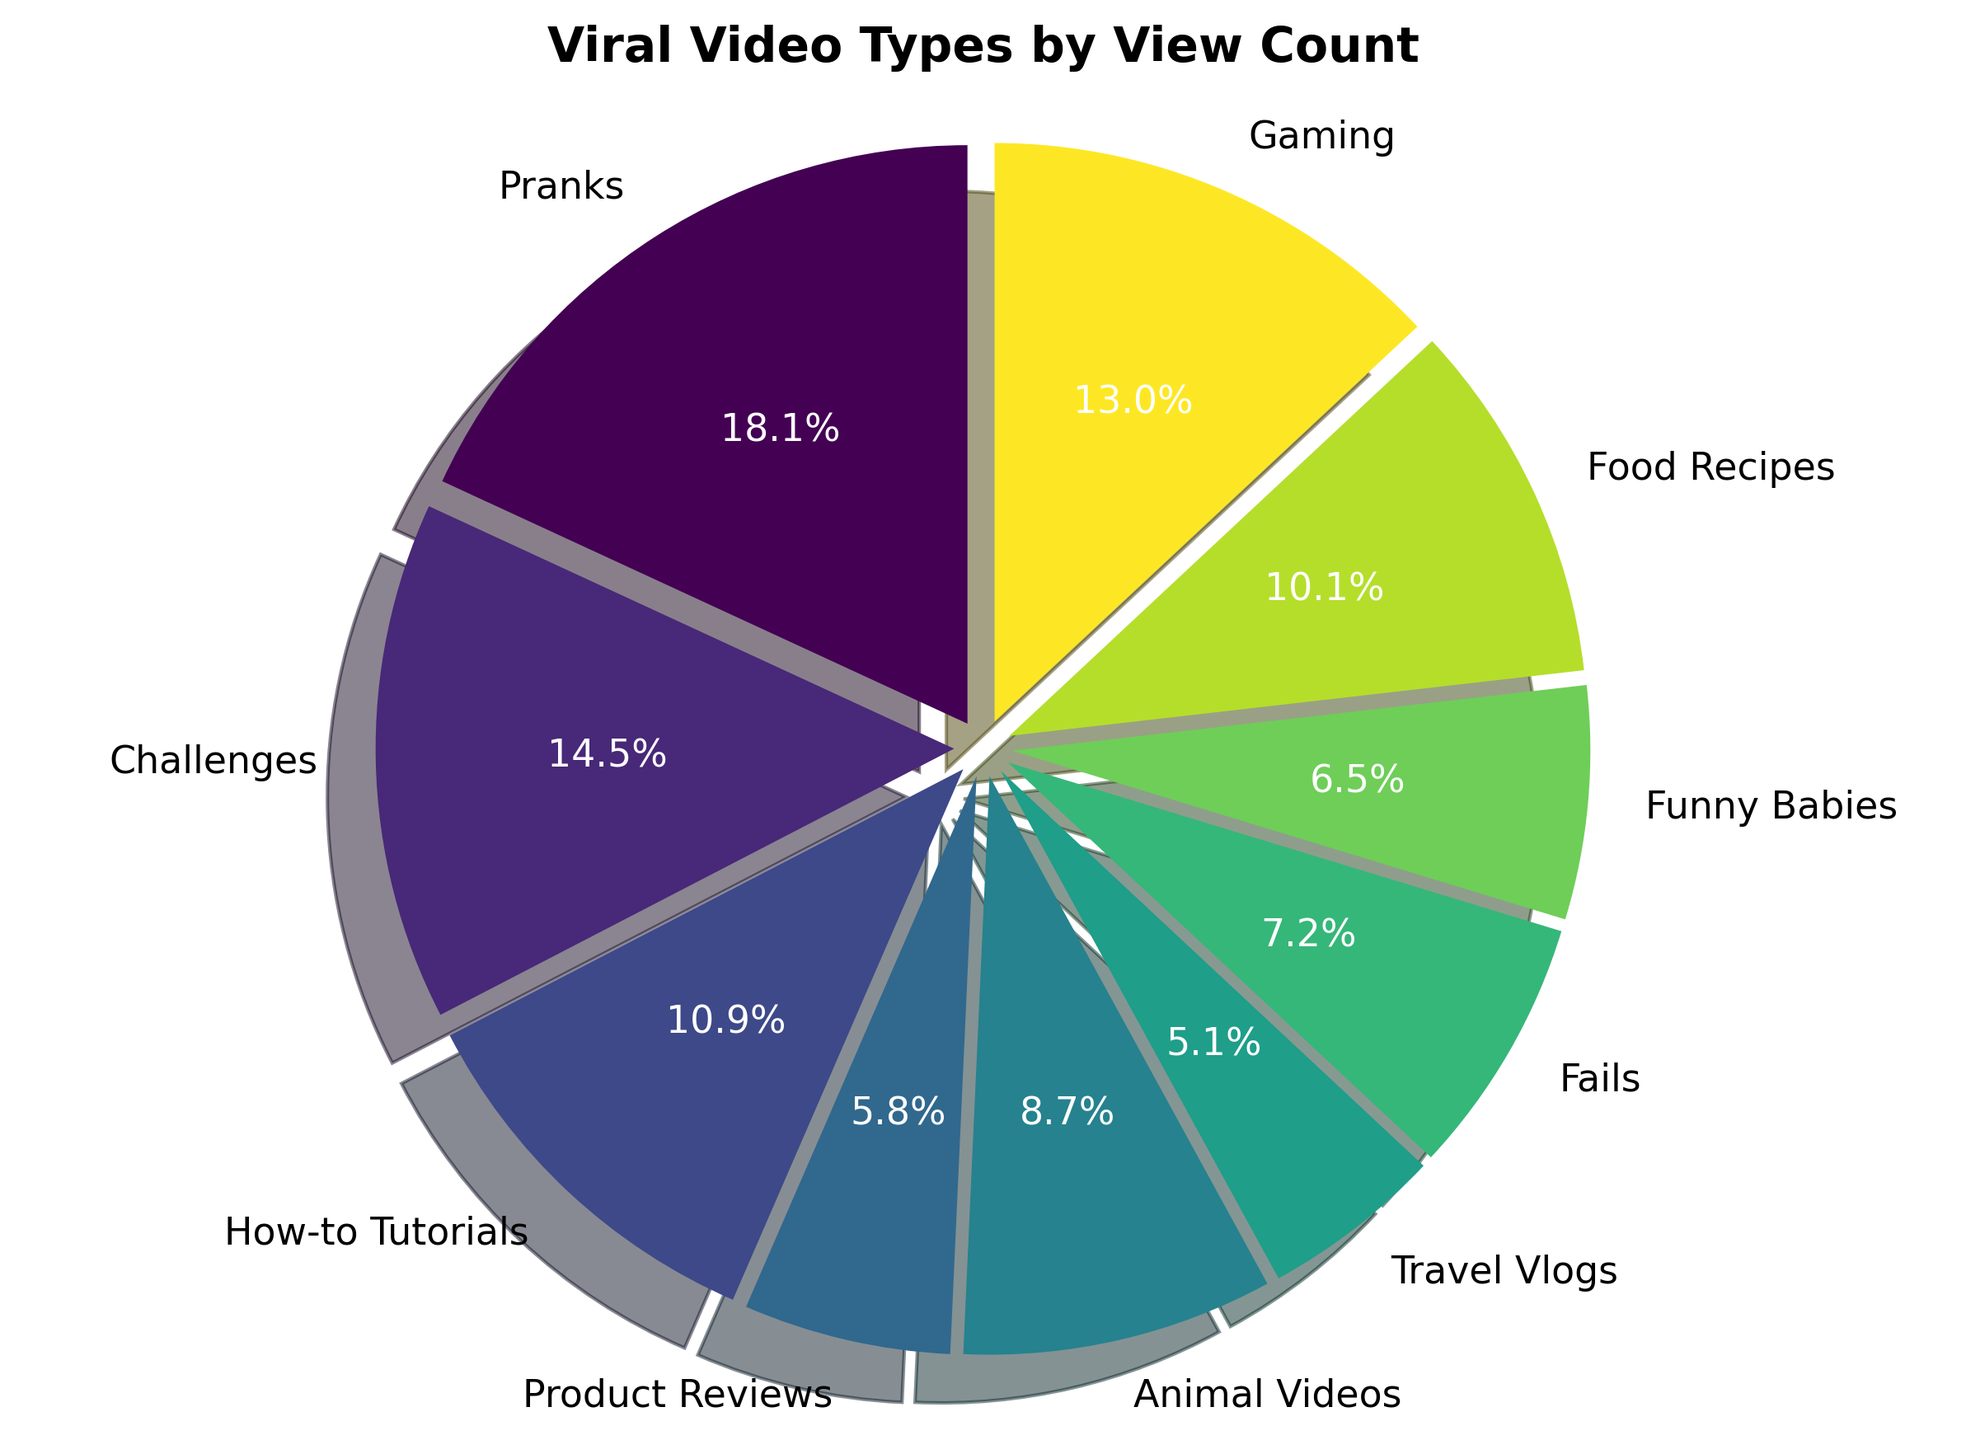Which viral video type has the highest view count? The pie chart shows the distribution of view counts for different video types. By looking at the size of the pie slices, we can see that "Pranks" has the largest slice, indicating the highest view count.
Answer: Pranks Which video type has a smaller view count: Travel Vlogs or Product Reviews? By comparing the sizes of the slices for "Travel Vlogs" and "Product Reviews," we can see that the slice for "Travel Vlogs" is smaller, indicating it has a lower view count.
Answer: Travel Vlogs How much larger is the view count for Food Recipes compared to Travel Vlogs? The pie chart shows percentages for each video type. The percentage for "Food Recipes" is 10.9%, and for "Travel Vlogs," it is 5.4%. The difference is 10.9% - 5.4% which translates back to view counts and gives us 14,000,000 for Food Recipes and 7,000,000 for Travel Vlogs. The difference in view count is 14,000,000 - 7,000,000 = 7,000,000.
Answer: 7,000,000 What is the combined view count percentage for Animal Videos, Funny Babies, and Fails? The pie chart gives the following percentages: Animal Videos 8.7%, Funny Babies 6.5%, and Fails 7.2%. Adding these percentages together gives 8.7% + 6.5% + 7.2% = 22.4%.
Answer: 22.4% Which type of video is third in terms of view count? By looking at the proportion of the pie chart segments, "Gaming" appears to be the third largest slice after "Pranks" and "Challenges."
Answer: Gaming What fraction of the total view count is attributed to how-to tutorials and gaming videos combined? The pie chart shows that "How-to Tutorials" have 10.9% and "Gaming" has 13.0% of the total view count. Combining these gives 10.9% + 13.0% = 23.9%. In fraction form, 23.9% is equivalent to 23.9/100 or 239/1000.
Answer: 239/1000 Is the percentage of view count for Challenges greater than, less than, or equal to that for Gaming? We compare the pie chart segments: "Challenges" have 17.4%, and "Gaming" has 13.0%. Therefore, the percentage of view count for Challenges is greater than that for Gaming.
Answer: Greater What is the total view count for videos other than Pranks? The total percentage for all video types is 100%. The percentage for Pranks is 21.7%. Therefore, the percentage for videos other than Pranks is 100% - 21.7% = 78.3%. To find the view count, calculate 78.3% of the total view count (105,000,000). So, 0.783 * 105,000,000 = 82,215,000.
Answer: 82,215,000 